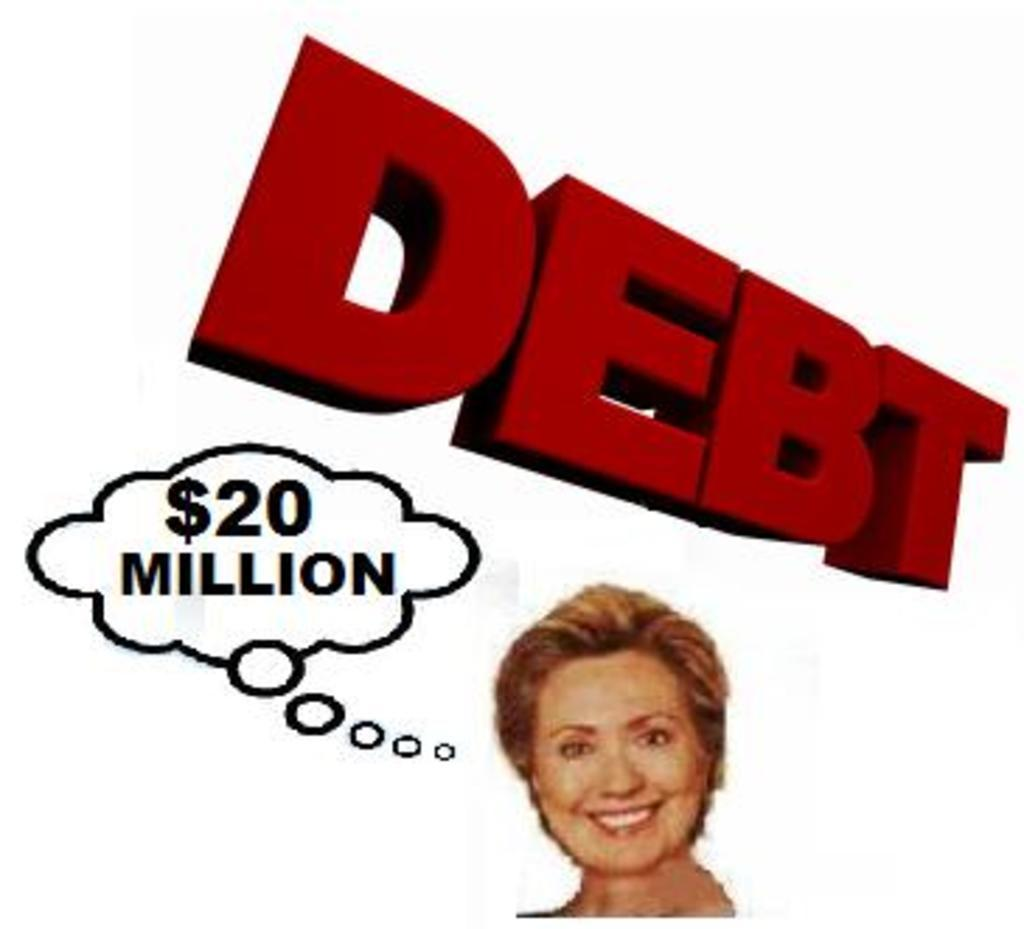Who or what is located at the bottom of the poster? There is a person at the bottom of the poster. What can be found in the center of the poster? There is text in the center of the poster. How many ducks are swimming in the text in the center of the poster? There are no ducks present in the poster; it only features a person at the bottom and text in the center. What type of pollution is depicted in the poster? There is no depiction of pollution in the poster; it only contains a person at the bottom and text in the center. 